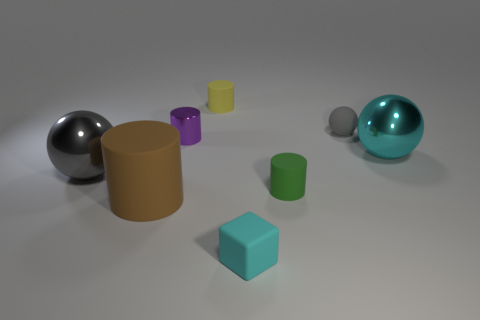Is there anything else that is the same shape as the tiny cyan object?
Ensure brevity in your answer.  No. There is a sphere in front of the big cyan ball; how big is it?
Provide a succinct answer. Large. Does the green cylinder have the same material as the tiny ball?
Give a very brief answer. Yes. There is a large sphere behind the big shiny sphere to the left of the purple shiny cylinder; are there any green objects that are left of it?
Give a very brief answer. Yes. The big cylinder has what color?
Your answer should be compact. Brown. The metallic object that is the same size as the cyan matte thing is what color?
Give a very brief answer. Purple. Does the large shiny object right of the purple cylinder have the same shape as the gray metal object?
Offer a very short reply. Yes. The large ball on the left side of the big object on the right side of the tiny matte cylinder that is behind the big cyan thing is what color?
Your response must be concise. Gray. Are there any gray matte objects?
Your answer should be very brief. Yes. How many other things are the same size as the cyan block?
Provide a succinct answer. 4. 